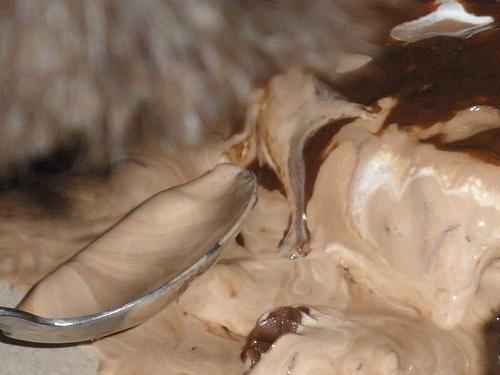How many spoons are there?
Give a very brief answer. 1. How many forks are there?
Give a very brief answer. 0. How many spoons are shown?
Give a very brief answer. 1. How many people eating the ice cream?
Give a very brief answer. 0. How many spoons are visible?
Give a very brief answer. 1. 